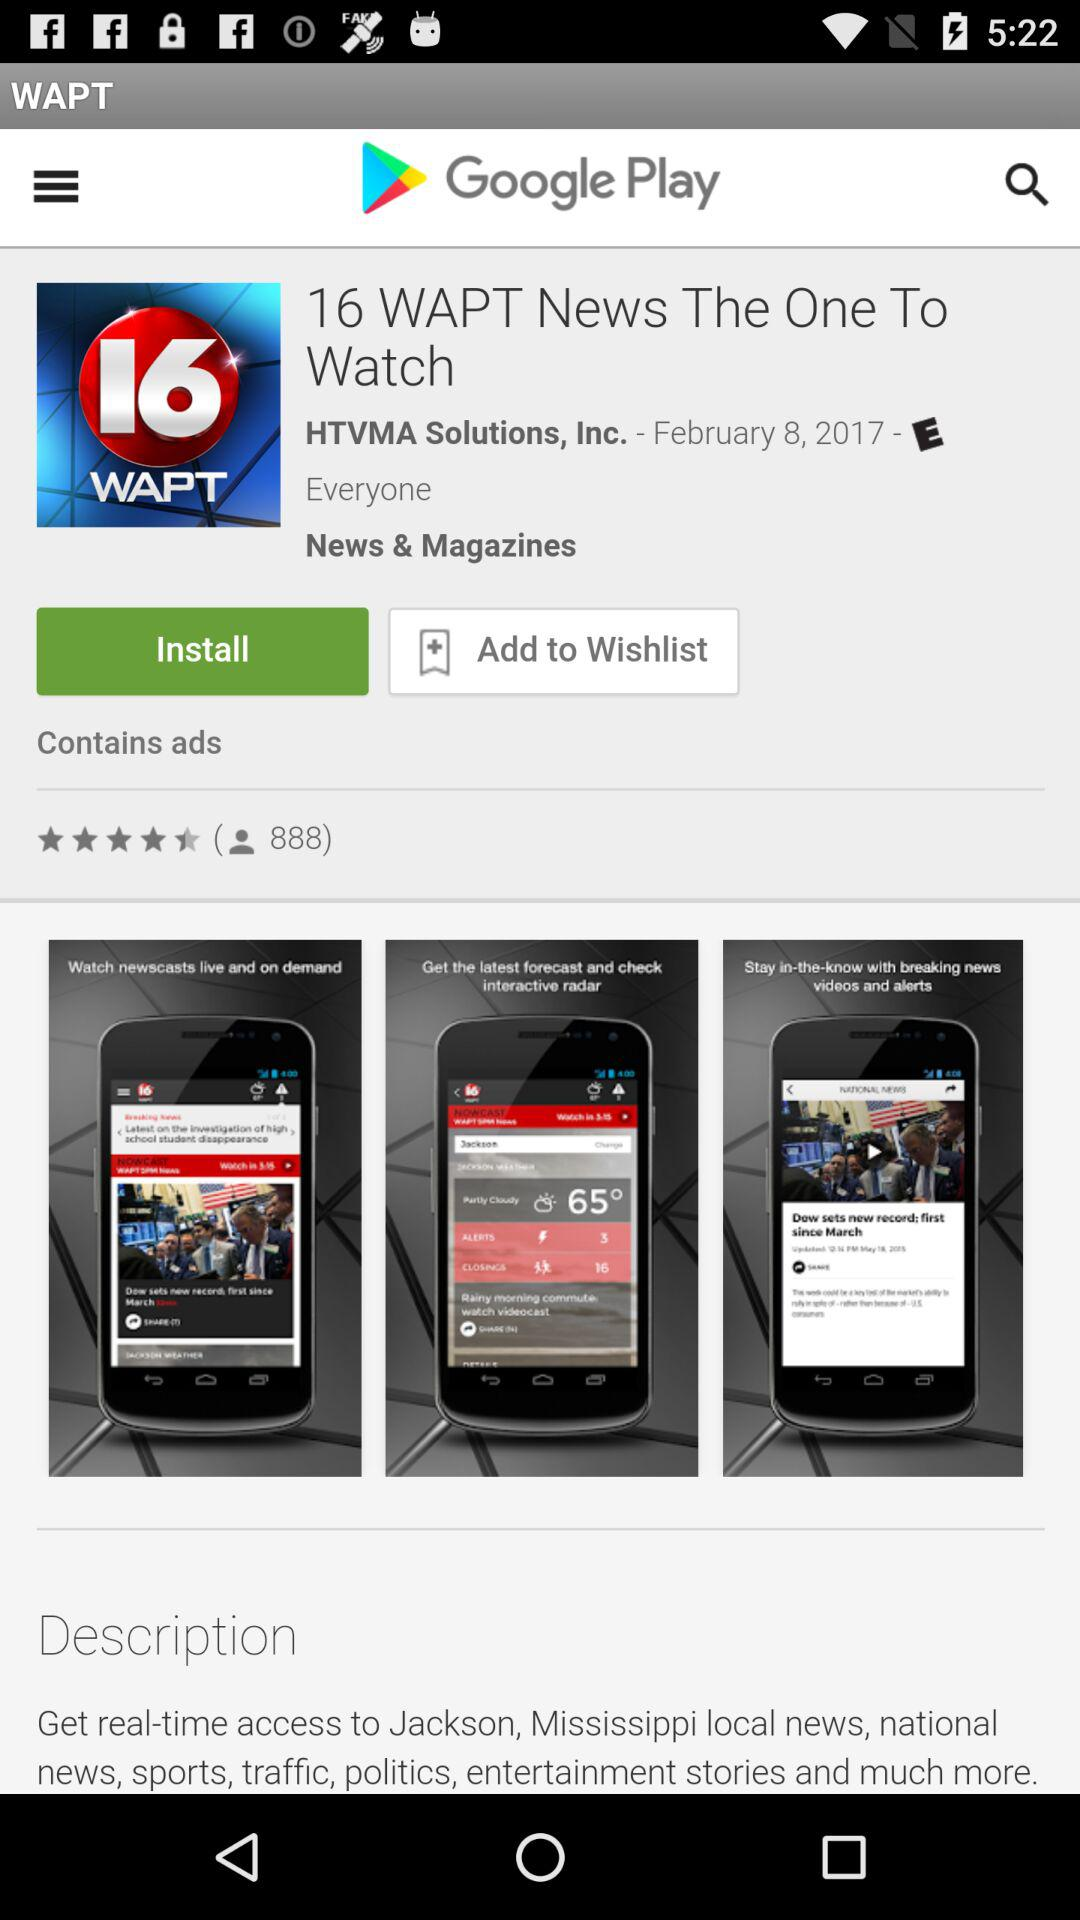Is this application added to the wishlist?
When the provided information is insufficient, respond with <no answer>. <no answer> 